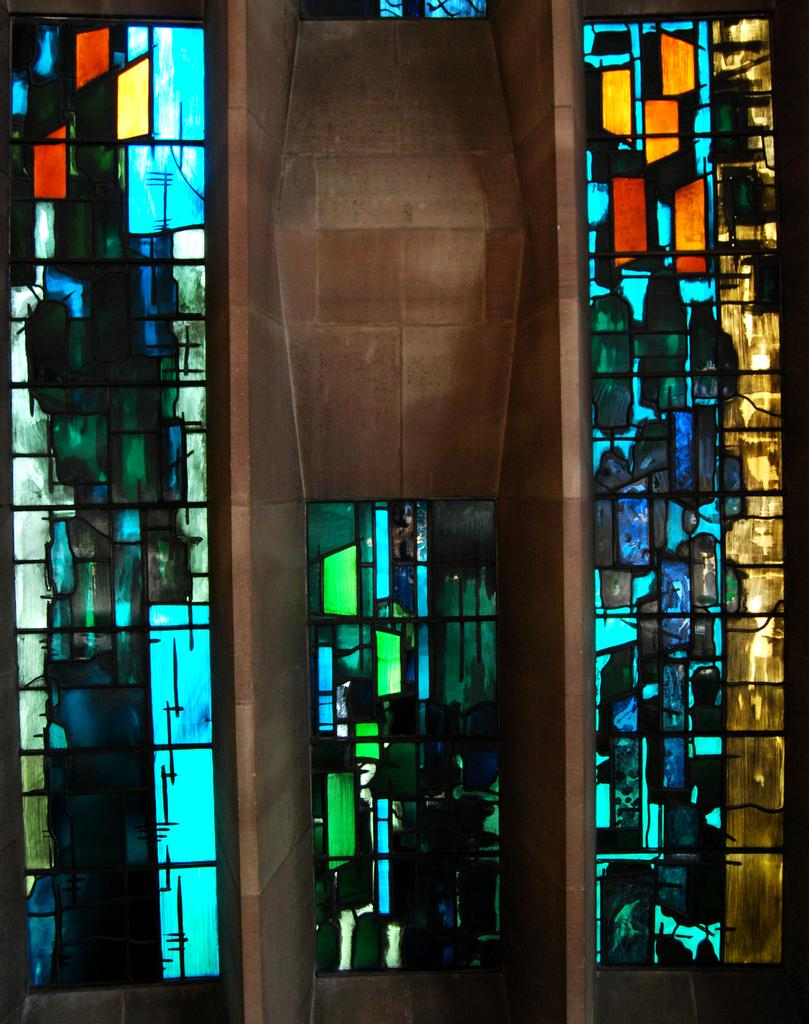What type of material is used to make one of the objects in the image? One of the objects in the image is made of wood. What type of material is used to make the other object in the image? The other object in the image is made of glass. Where are both objects located in the image? Both objects are present in the middle of the image. What is the effect of the thumb on the wooden object in the image? There is no thumb present in the image, so it cannot have any effect on the wooden object. 